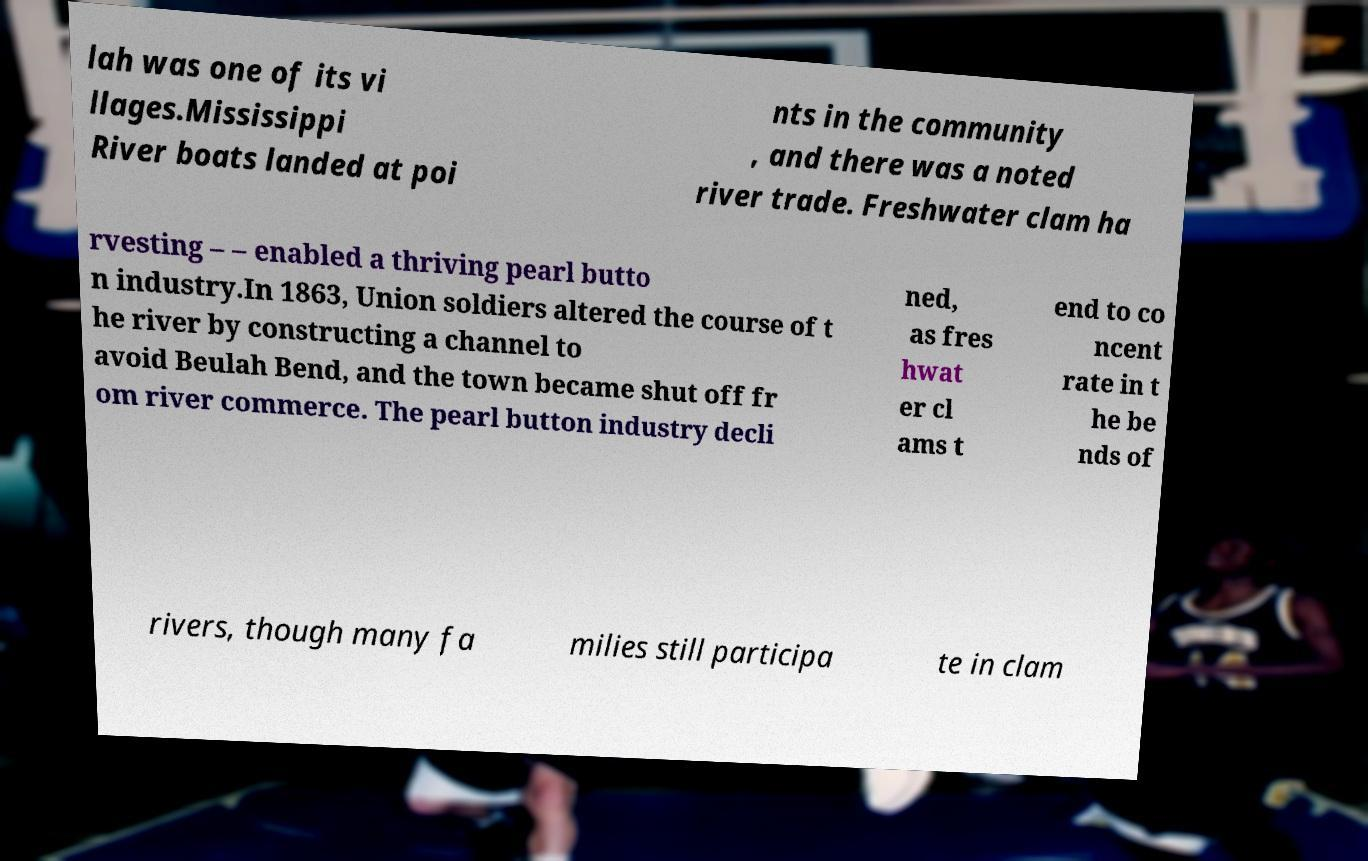For documentation purposes, I need the text within this image transcribed. Could you provide that? lah was one of its vi llages.Mississippi River boats landed at poi nts in the community , and there was a noted river trade. Freshwater clam ha rvesting – – enabled a thriving pearl butto n industry.In 1863, Union soldiers altered the course of t he river by constructing a channel to avoid Beulah Bend, and the town became shut off fr om river commerce. The pearl button industry decli ned, as fres hwat er cl ams t end to co ncent rate in t he be nds of rivers, though many fa milies still participa te in clam 